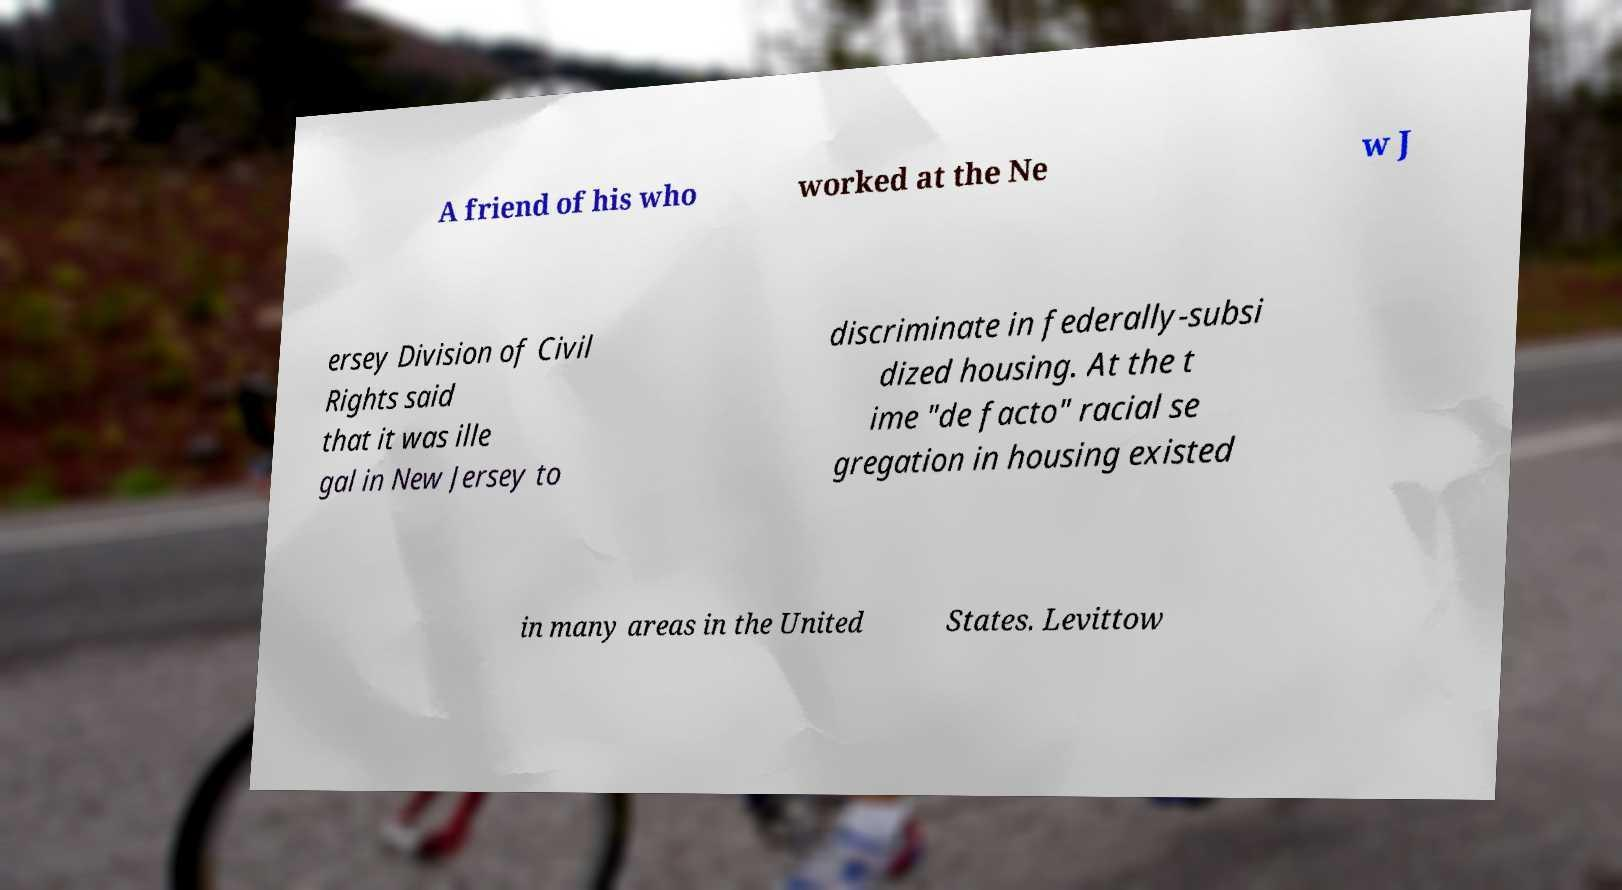Please read and relay the text visible in this image. What does it say? A friend of his who worked at the Ne w J ersey Division of Civil Rights said that it was ille gal in New Jersey to discriminate in federally-subsi dized housing. At the t ime "de facto" racial se gregation in housing existed in many areas in the United States. Levittow 